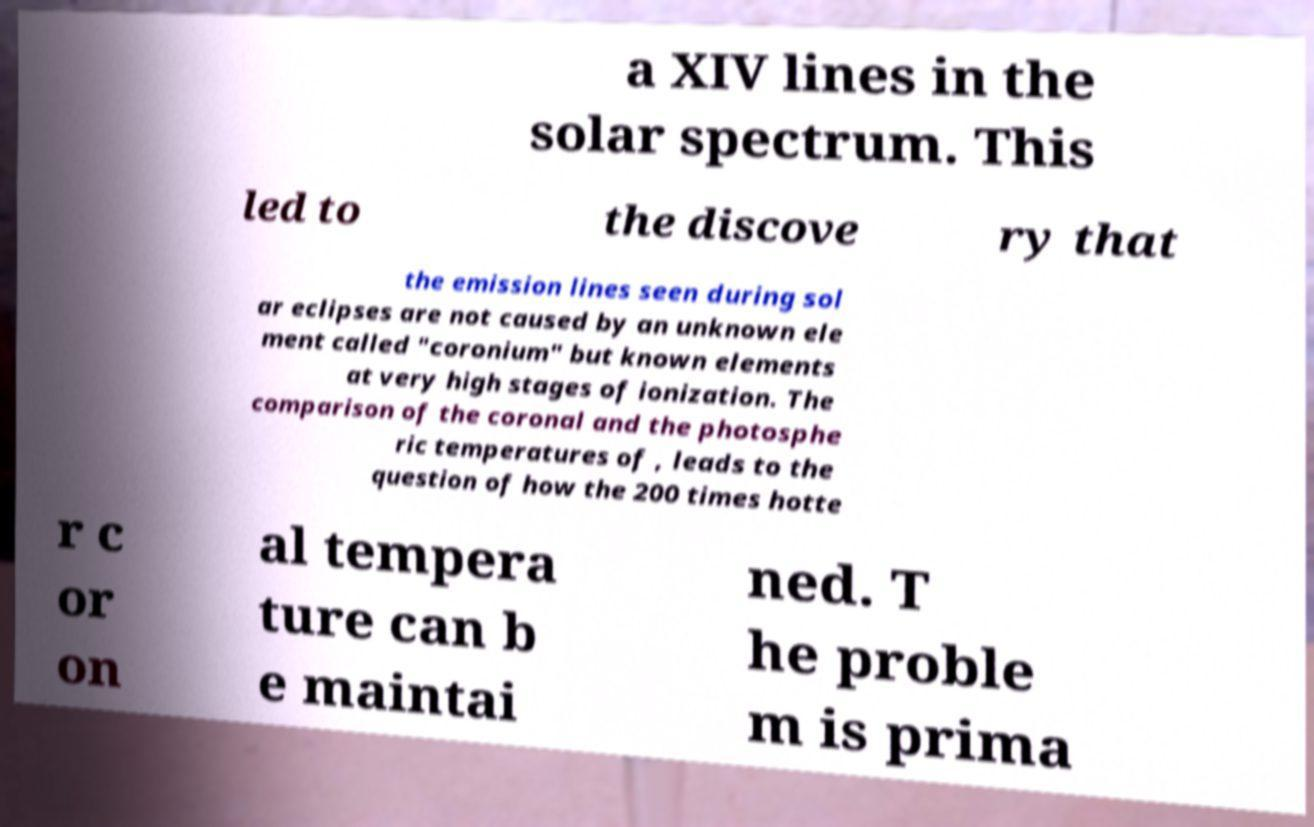Could you extract and type out the text from this image? a XIV lines in the solar spectrum. This led to the discove ry that the emission lines seen during sol ar eclipses are not caused by an unknown ele ment called "coronium" but known elements at very high stages of ionization. The comparison of the coronal and the photosphe ric temperatures of , leads to the question of how the 200 times hotte r c or on al tempera ture can b e maintai ned. T he proble m is prima 